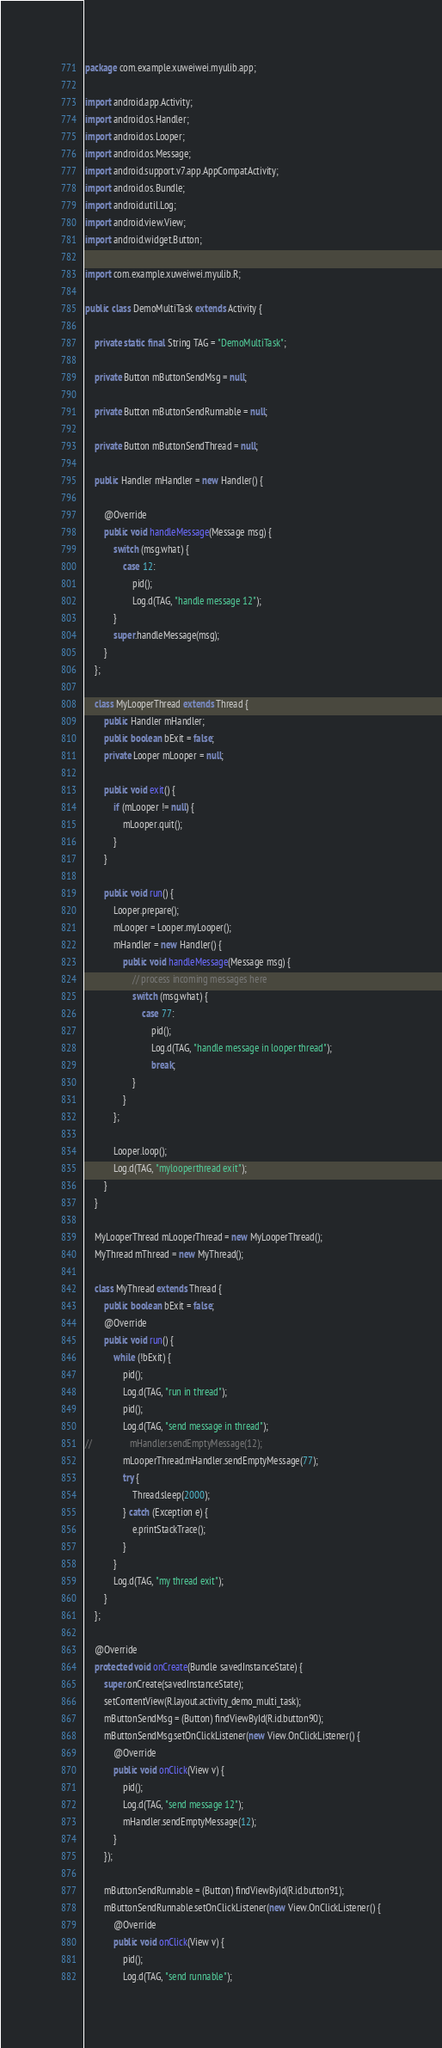Convert code to text. <code><loc_0><loc_0><loc_500><loc_500><_Java_>package com.example.xuweiwei.myulib.app;

import android.app.Activity;
import android.os.Handler;
import android.os.Looper;
import android.os.Message;
import android.support.v7.app.AppCompatActivity;
import android.os.Bundle;
import android.util.Log;
import android.view.View;
import android.widget.Button;

import com.example.xuweiwei.myulib.R;

public class DemoMultiTask extends Activity {

    private static final String TAG = "DemoMultiTask";

    private Button mButtonSendMsg = null;

    private Button mButtonSendRunnable = null;

    private Button mButtonSendThread = null;

    public Handler mHandler = new Handler() {

        @Override
        public void handleMessage(Message msg) {
            switch (msg.what) {
                case 12:
                    pid();
                    Log.d(TAG, "handle message 12");
            }
            super.handleMessage(msg);
        }
    };

    class MyLooperThread extends Thread {
        public Handler mHandler;
        public boolean bExit = false;
        private Looper mLooper = null;

        public void exit() {
            if (mLooper != null) {
                mLooper.quit();
            }
        }

        public void run() {
            Looper.prepare();
            mLooper = Looper.myLooper();
            mHandler = new Handler() {
                public void handleMessage(Message msg) {
                    // process incoming messages here
                    switch (msg.what) {
                        case 77:
                            pid();
                            Log.d(TAG, "handle message in looper thread");
                            break;
                    }
                }
            };

            Looper.loop();
            Log.d(TAG, "mylooperthread exit");
        }
    }

    MyLooperThread mLooperThread = new MyLooperThread();
    MyThread mThread = new MyThread();

    class MyThread extends Thread {
        public boolean bExit = false;
        @Override
        public void run() {
            while (!bExit) {
                pid();
                Log.d(TAG, "run in thread");
                pid();
                Log.d(TAG, "send message in thread");
//                mHandler.sendEmptyMessage(12);
                mLooperThread.mHandler.sendEmptyMessage(77);
                try {
                    Thread.sleep(2000);
                } catch (Exception e) {
                    e.printStackTrace();
                }
            }
            Log.d(TAG, "my thread exit");
        }
    };

    @Override
    protected void onCreate(Bundle savedInstanceState) {
        super.onCreate(savedInstanceState);
        setContentView(R.layout.activity_demo_multi_task);
        mButtonSendMsg = (Button) findViewById(R.id.button90);
        mButtonSendMsg.setOnClickListener(new View.OnClickListener() {
            @Override
            public void onClick(View v) {
                pid();
                Log.d(TAG, "send message 12");
                mHandler.sendEmptyMessage(12);
            }
        });

        mButtonSendRunnable = (Button) findViewById(R.id.button91);
        mButtonSendRunnable.setOnClickListener(new View.OnClickListener() {
            @Override
            public void onClick(View v) {
                pid();
                Log.d(TAG, "send runnable");</code> 